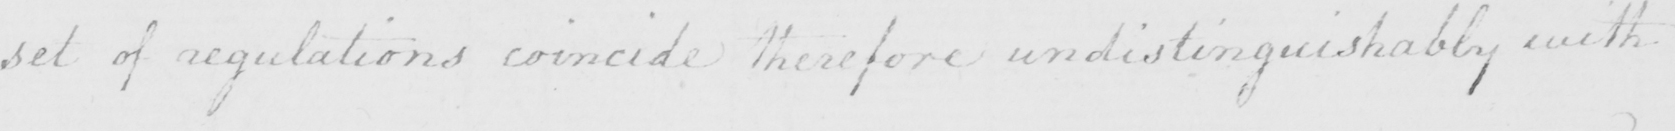What is written in this line of handwriting? set of regulations coincide therefore undistinguishably with 